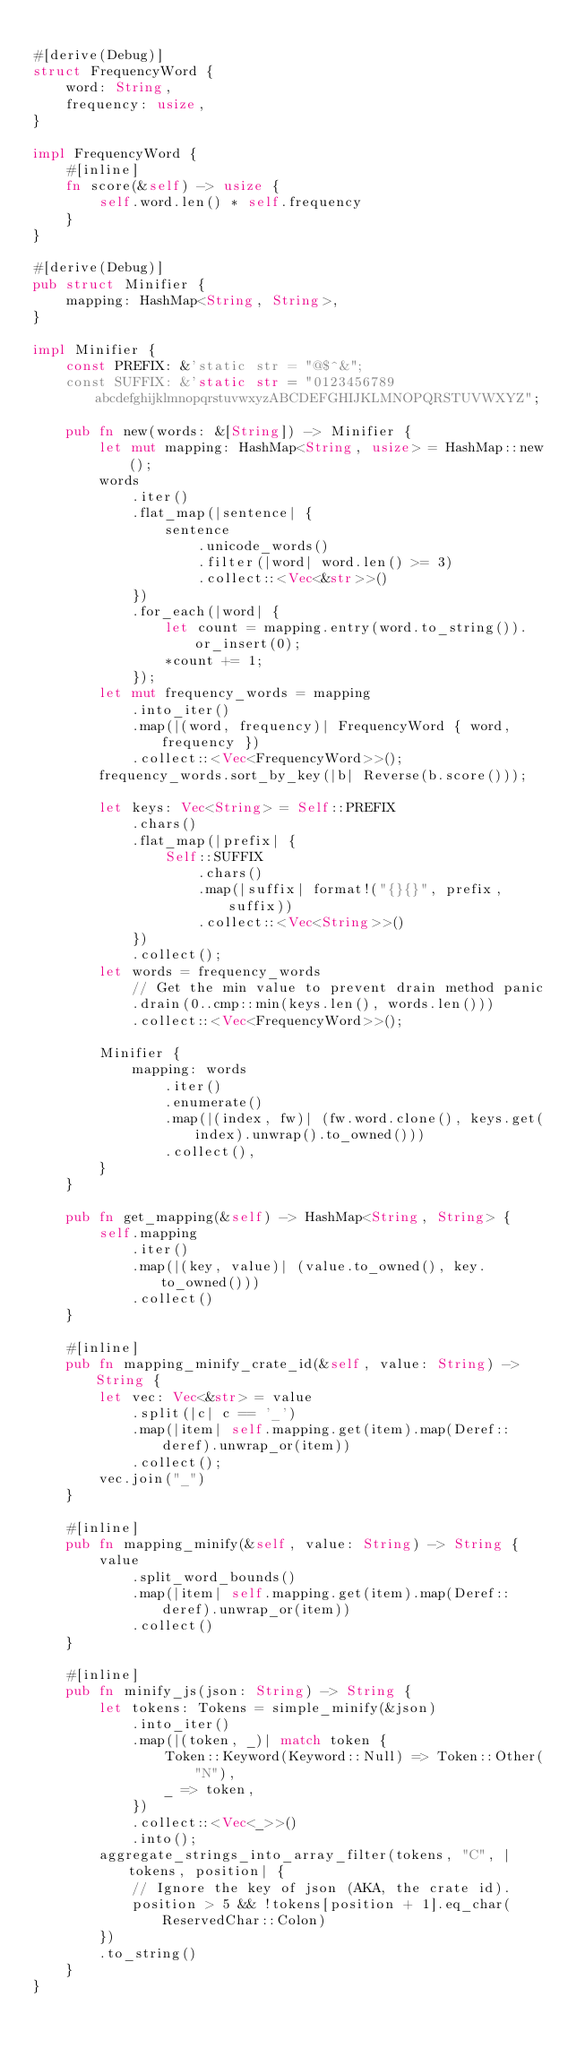Convert code to text. <code><loc_0><loc_0><loc_500><loc_500><_Rust_>
#[derive(Debug)]
struct FrequencyWord {
    word: String,
    frequency: usize,
}

impl FrequencyWord {
    #[inline]
    fn score(&self) -> usize {
        self.word.len() * self.frequency
    }
}

#[derive(Debug)]
pub struct Minifier {
    mapping: HashMap<String, String>,
}

impl Minifier {
    const PREFIX: &'static str = "@$^&";
    const SUFFIX: &'static str = "0123456789abcdefghijklmnopqrstuvwxyzABCDEFGHIJKLMNOPQRSTUVWXYZ";

    pub fn new(words: &[String]) -> Minifier {
        let mut mapping: HashMap<String, usize> = HashMap::new();
        words
            .iter()
            .flat_map(|sentence| {
                sentence
                    .unicode_words()
                    .filter(|word| word.len() >= 3)
                    .collect::<Vec<&str>>()
            })
            .for_each(|word| {
                let count = mapping.entry(word.to_string()).or_insert(0);
                *count += 1;
            });
        let mut frequency_words = mapping
            .into_iter()
            .map(|(word, frequency)| FrequencyWord { word, frequency })
            .collect::<Vec<FrequencyWord>>();
        frequency_words.sort_by_key(|b| Reverse(b.score()));

        let keys: Vec<String> = Self::PREFIX
            .chars()
            .flat_map(|prefix| {
                Self::SUFFIX
                    .chars()
                    .map(|suffix| format!("{}{}", prefix, suffix))
                    .collect::<Vec<String>>()
            })
            .collect();
        let words = frequency_words
            // Get the min value to prevent drain method panic
            .drain(0..cmp::min(keys.len(), words.len()))
            .collect::<Vec<FrequencyWord>>();

        Minifier {
            mapping: words
                .iter()
                .enumerate()
                .map(|(index, fw)| (fw.word.clone(), keys.get(index).unwrap().to_owned()))
                .collect(),
        }
    }

    pub fn get_mapping(&self) -> HashMap<String, String> {
        self.mapping
            .iter()
            .map(|(key, value)| (value.to_owned(), key.to_owned()))
            .collect()
    }

    #[inline]
    pub fn mapping_minify_crate_id(&self, value: String) -> String {
        let vec: Vec<&str> = value
            .split(|c| c == '_')
            .map(|item| self.mapping.get(item).map(Deref::deref).unwrap_or(item))
            .collect();
        vec.join("_")
    }

    #[inline]
    pub fn mapping_minify(&self, value: String) -> String {
        value
            .split_word_bounds()
            .map(|item| self.mapping.get(item).map(Deref::deref).unwrap_or(item))
            .collect()
    }

    #[inline]
    pub fn minify_js(json: String) -> String {
        let tokens: Tokens = simple_minify(&json)
            .into_iter()
            .map(|(token, _)| match token {
                Token::Keyword(Keyword::Null) => Token::Other("N"),
                _ => token,
            })
            .collect::<Vec<_>>()
            .into();
        aggregate_strings_into_array_filter(tokens, "C", |tokens, position| {
            // Ignore the key of json (AKA, the crate id).
            position > 5 && !tokens[position + 1].eq_char(ReservedChar::Colon)
        })
        .to_string()
    }
}
</code> 